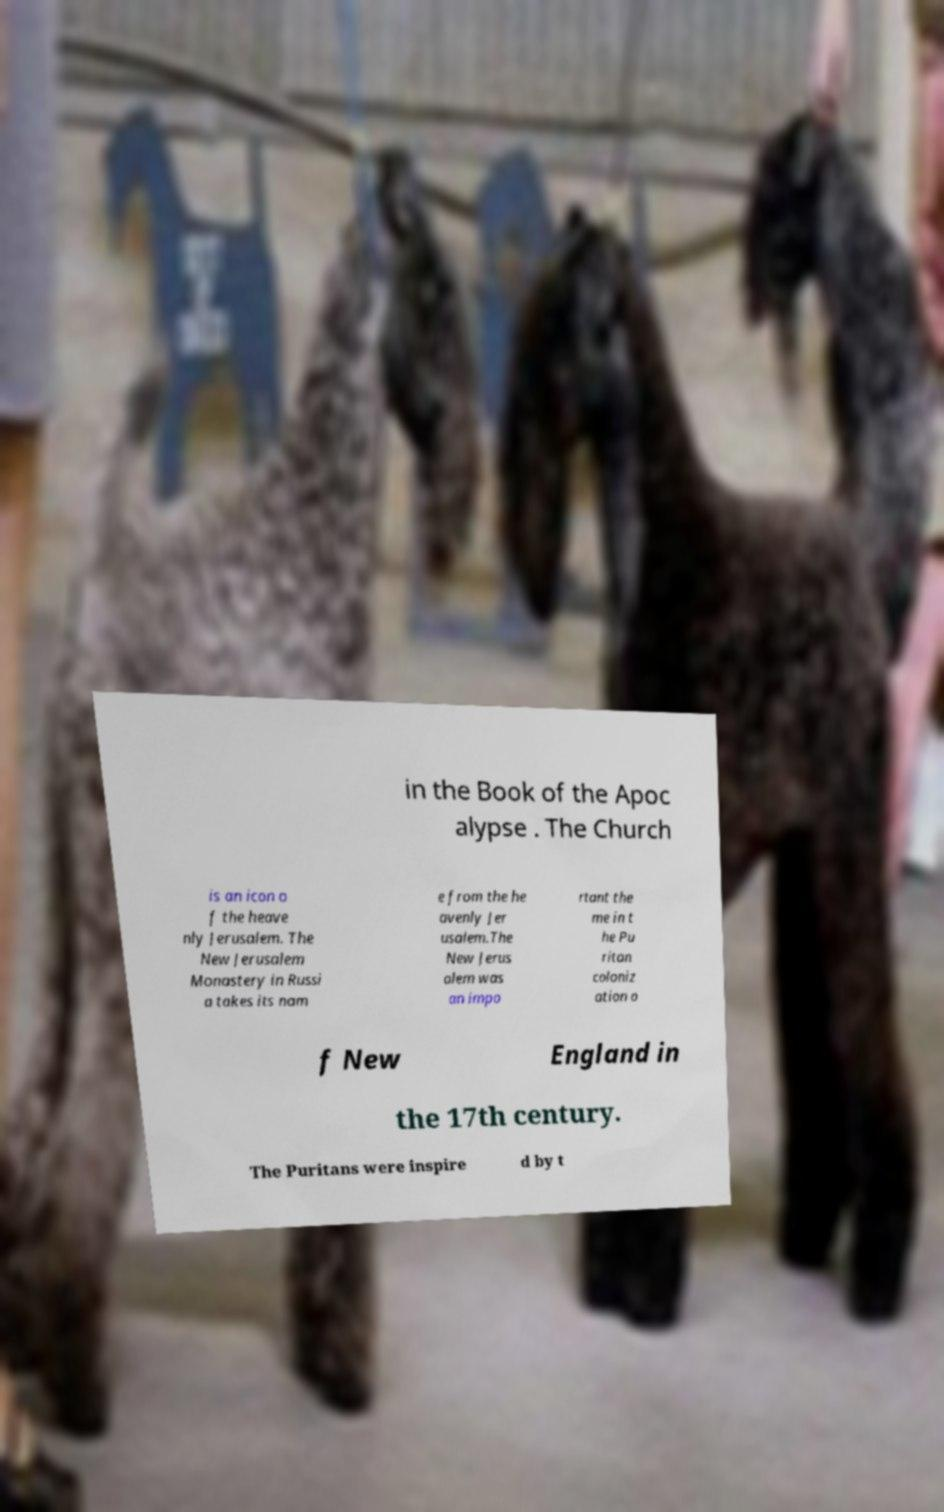Could you extract and type out the text from this image? in the Book of the Apoc alypse . The Church is an icon o f the heave nly Jerusalem. The New Jerusalem Monastery in Russi a takes its nam e from the he avenly Jer usalem.The New Jerus alem was an impo rtant the me in t he Pu ritan coloniz ation o f New England in the 17th century. The Puritans were inspire d by t 